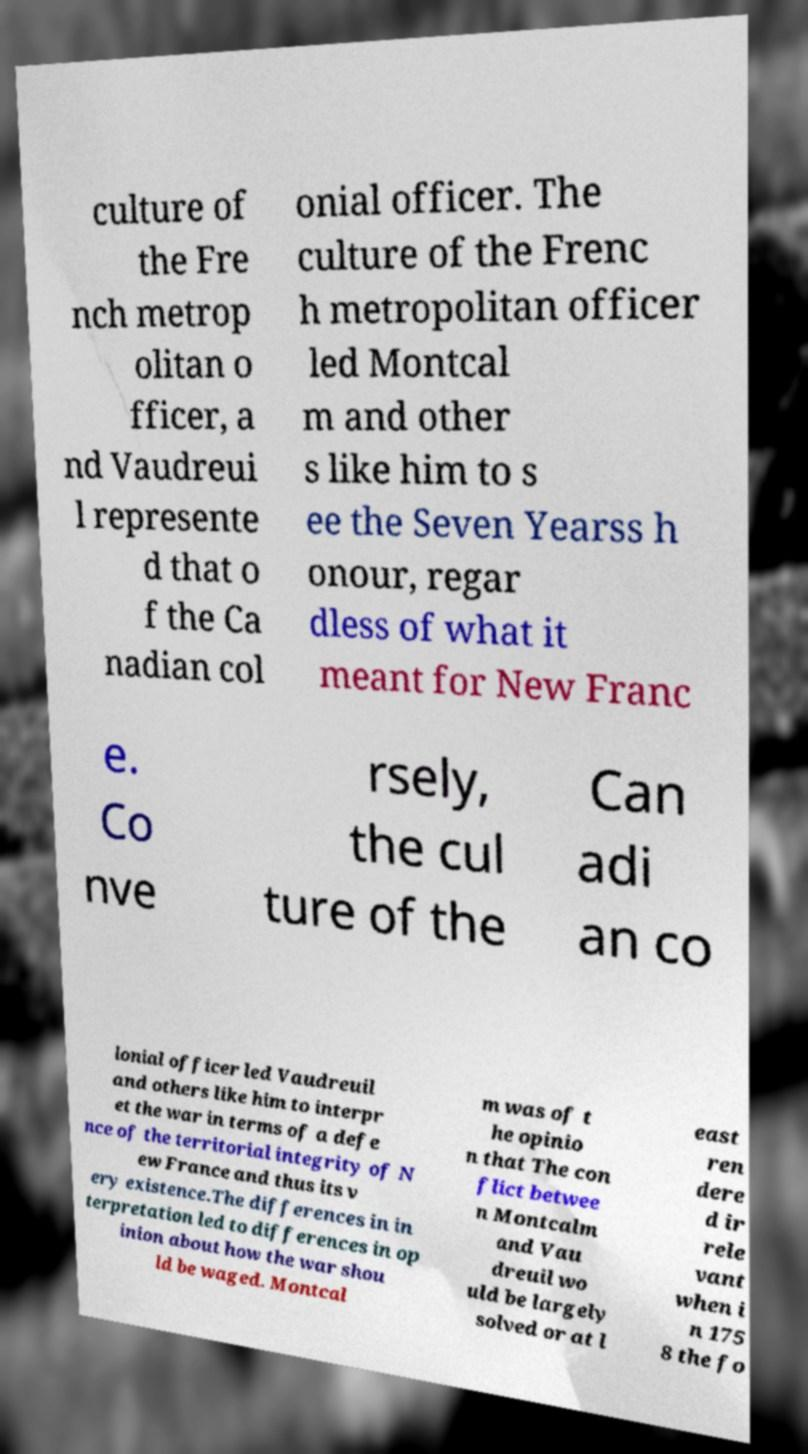For documentation purposes, I need the text within this image transcribed. Could you provide that? culture of the Fre nch metrop olitan o fficer, a nd Vaudreui l represente d that o f the Ca nadian col onial officer. The culture of the Frenc h metropolitan officer led Montcal m and other s like him to s ee the Seven Yearss h onour, regar dless of what it meant for New Franc e. Co nve rsely, the cul ture of the Can adi an co lonial officer led Vaudreuil and others like him to interpr et the war in terms of a defe nce of the territorial integrity of N ew France and thus its v ery existence.The differences in in terpretation led to differences in op inion about how the war shou ld be waged. Montcal m was of t he opinio n that The con flict betwee n Montcalm and Vau dreuil wo uld be largely solved or at l east ren dere d ir rele vant when i n 175 8 the fo 